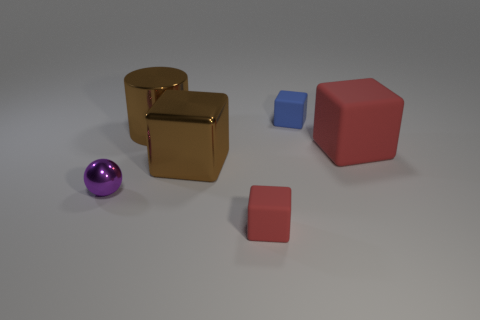Subtract all gray blocks. Subtract all red cylinders. How many blocks are left? 4 Add 4 big brown shiny things. How many objects exist? 10 Subtract all cylinders. How many objects are left? 5 Add 2 purple shiny things. How many purple shiny things exist? 3 Subtract 1 purple spheres. How many objects are left? 5 Subtract all small gray spheres. Subtract all small things. How many objects are left? 3 Add 4 big red cubes. How many big red cubes are left? 5 